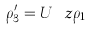<formula> <loc_0><loc_0><loc_500><loc_500>\rho ^ { \prime } _ { 3 } = U _ { \ } z \rho _ { 1 }</formula> 